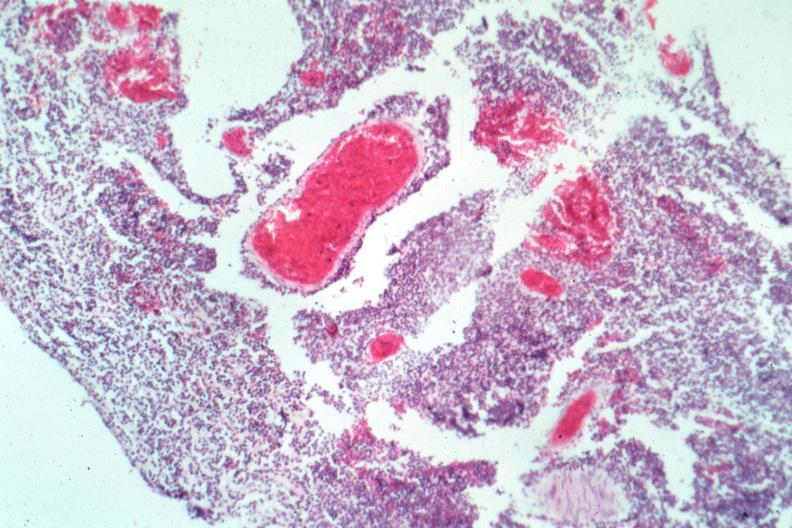s meningitis acute present?
Answer the question using a single word or phrase. Yes 